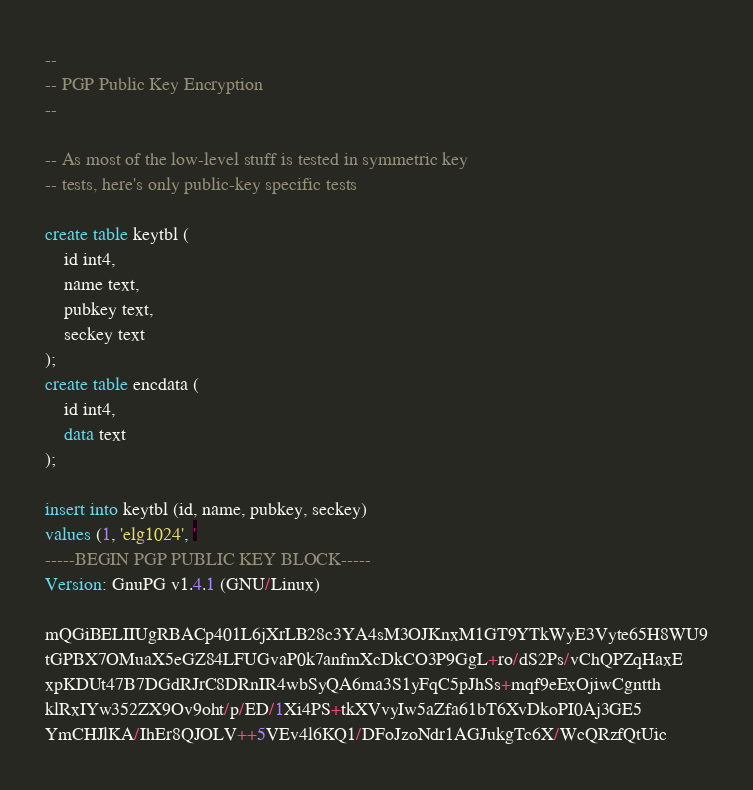<code> <loc_0><loc_0><loc_500><loc_500><_SQL_>--
-- PGP Public Key Encryption
--

-- As most of the low-level stuff is tested in symmetric key
-- tests, here's only public-key specific tests

create table keytbl (
	id int4,
	name text,
	pubkey text,
	seckey text
);
create table encdata (
	id int4,
	data text
);

insert into keytbl (id, name, pubkey, seckey)
values (1, 'elg1024', '
-----BEGIN PGP PUBLIC KEY BLOCK-----
Version: GnuPG v1.4.1 (GNU/Linux)

mQGiBELIIUgRBACp401L6jXrLB28c3YA4sM3OJKnxM1GT9YTkWyE3Vyte65H8WU9
tGPBX7OMuaX5eGZ84LFUGvaP0k7anfmXcDkCO3P9GgL+ro/dS2Ps/vChQPZqHaxE
xpKDUt47B7DGdRJrC8DRnIR4wbSyQA6ma3S1yFqC5pJhSs+mqf9eExOjiwCgntth
klRxIYw352ZX9Ov9oht/p/ED/1Xi4PS+tkXVvyIw5aZfa61bT6XvDkoPI0Aj3GE5
YmCHJlKA/IhEr8QJOLV++5VEv4l6KQ1/DFoJzoNdr1AGJukgTc6X/WcQRzfQtUic</code> 